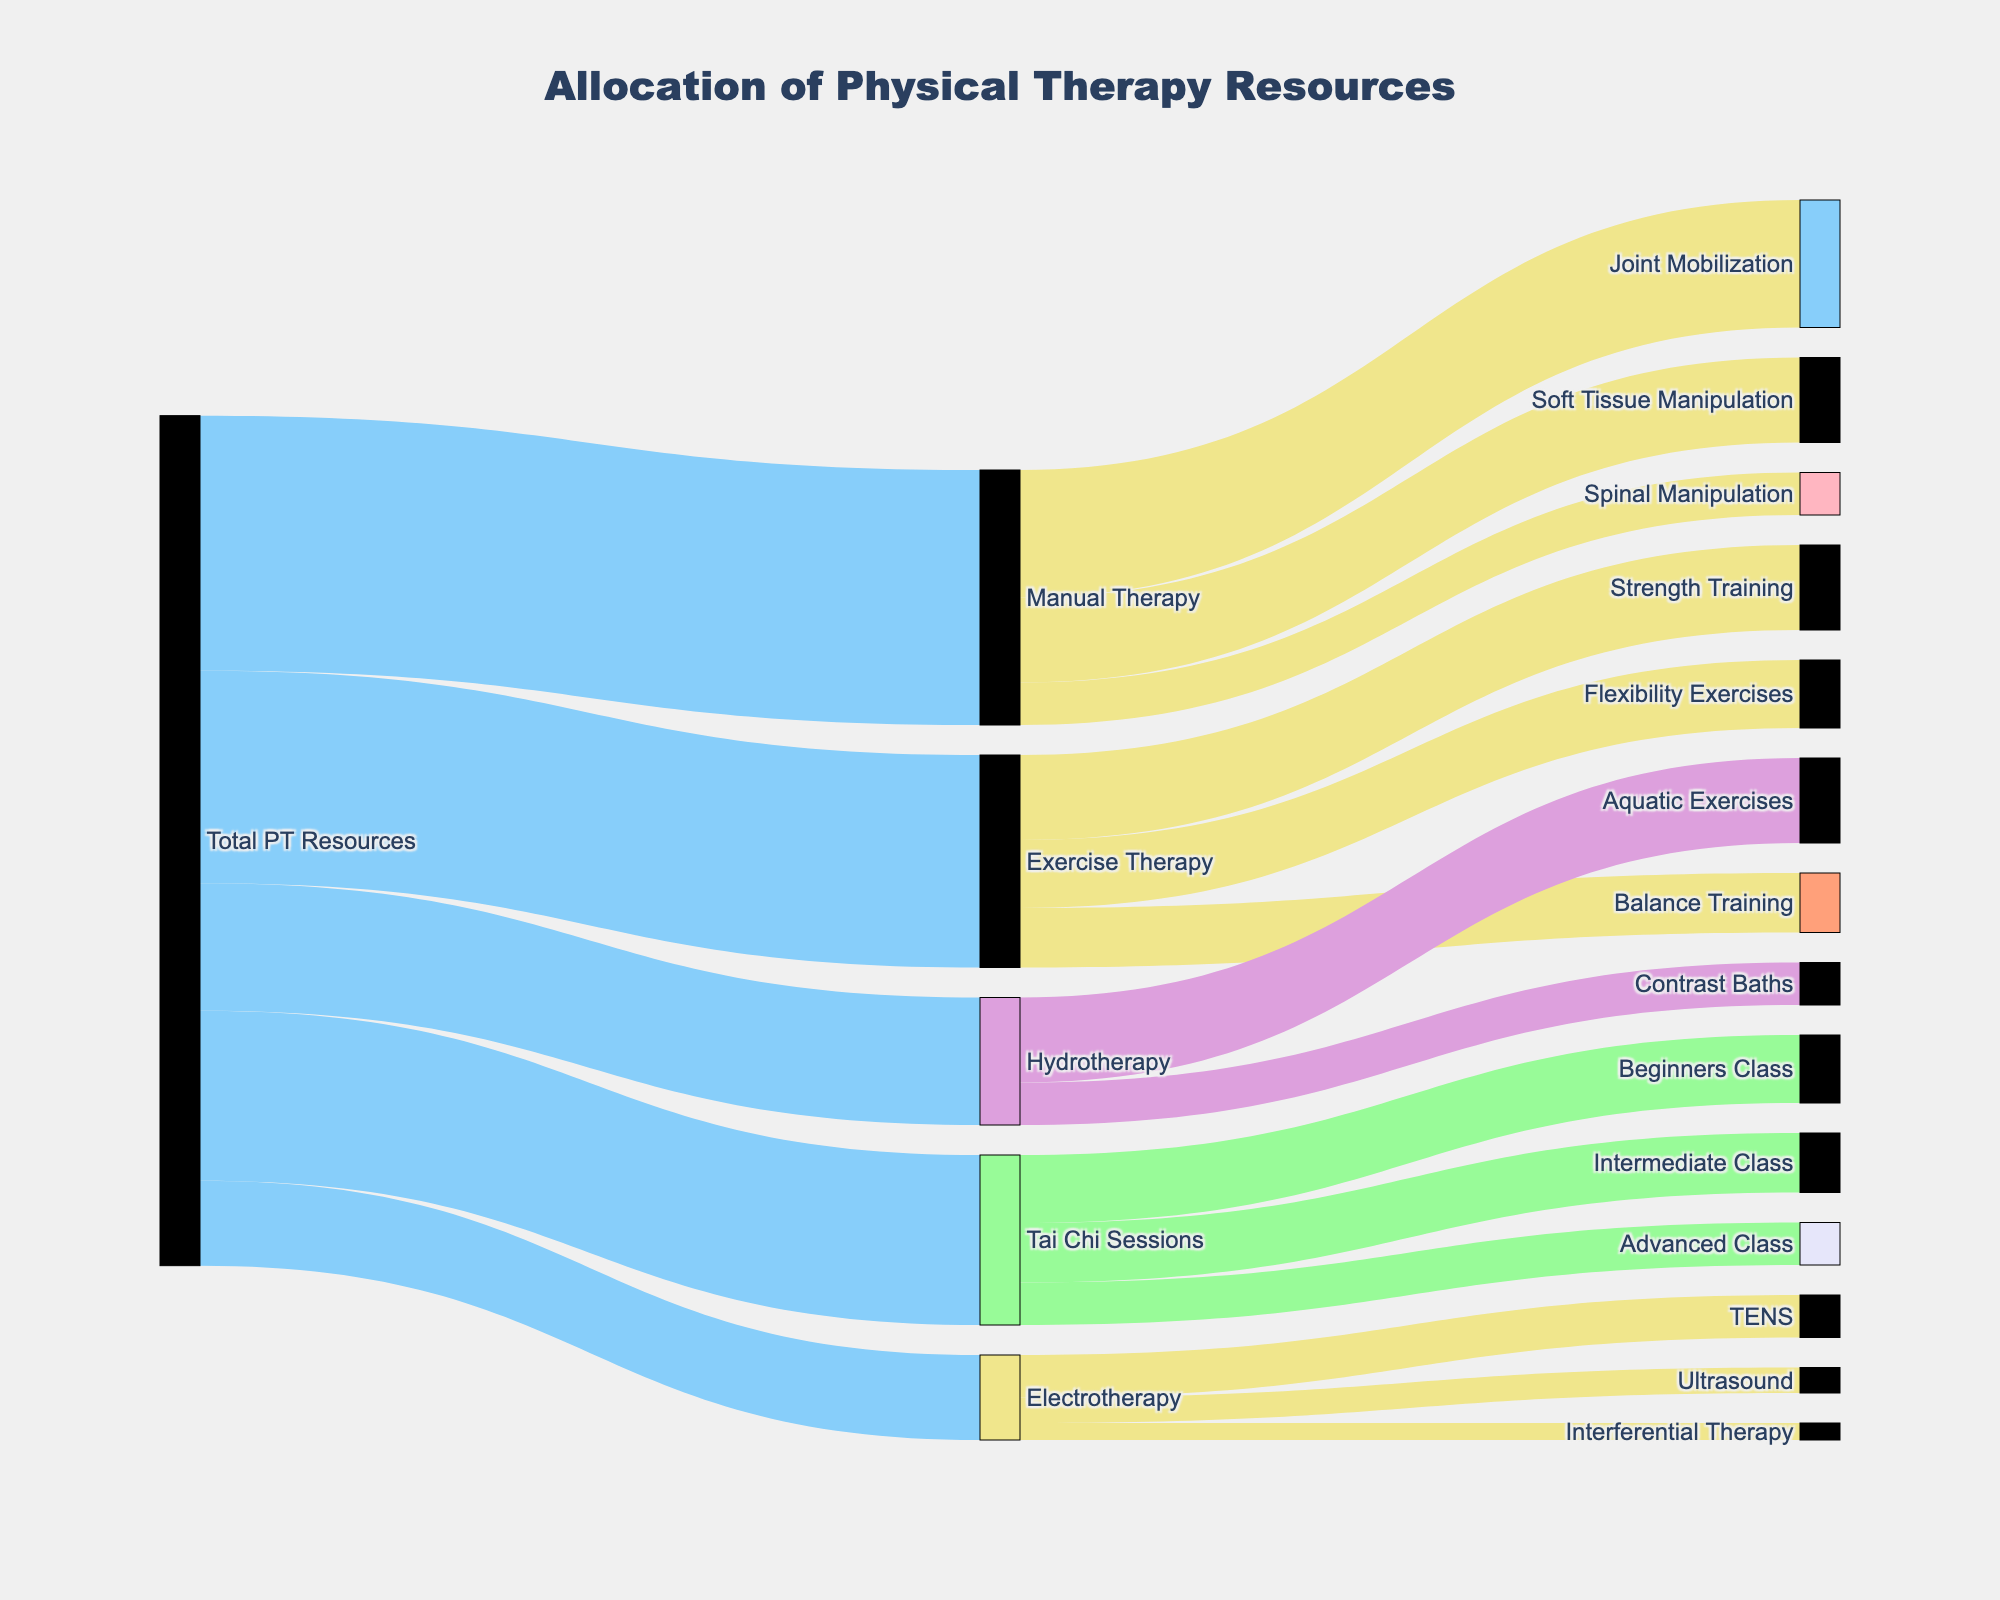What is the title of the figure? The title of the figure is displayed at the top and it reads "Allocation of Physical Therapy Resources".
Answer: Allocation of Physical Therapy Resources Which treatment modality received the most resources from the total physical therapy resources? The largest portion of the total physical therapy resources is allocated to Manual Therapy, as indicated by the widest link originating from "Total PT Resources" and flowing to "Manual Therapy".
Answer: Manual Therapy How many treatment modalities are listed for total physical therapy resources? By counting the number of distinct links originating from "Total PT Resources," we can identify five treatment modalities.
Answer: Five What is the combined value of the resources allocated to the Exercise Therapy subcategories? The subcategories under Exercise Therapy are Strength Training, Flexibility Exercises, and Balance Training, with values of 10, 8, and 7 respectively. Summing these up, 10 + 8 + 7 = 25.
Answer: 25 What is the value allocated to Tai Chi Sessions, and how does it compare to Hydrotherapy? The value allocated to Tai Chi Sessions is 20, while Hydrotherapy received 15. By comparison, Tai Chi Sessions have 5 more resources allocated than Hydrotherapy.
Answer: Tai Chi Sessions have 5 more resources than Hydrotherapy Which Tai Chi class received the least resources? By looking at the links originating from "Tai Chi Sessions" and checking their values, the class with the smallest value is the Advanced Class, receiving 5 resources.
Answer: Advanced Class How many total resources are split among the categories under Manual Therapy? The categories under Manual Therapy are Joint Mobilization (15), Soft Tissue Manipulation (10), and Spinal Manipulation (5). Summing these values, 15 + 10 + 5 = 30.
Answer: 30 Compare the allocation between Joint Mobilization and Spinal Manipulation within Manual Therapy. Joint Mobilization is allocated 15 resources, while Spinal Manipulation is allocated 5. Joint Mobilization receives three times the resources of Spinal Manipulation (15/5 = 3).
Answer: Joint Mobilization receives three times the resources How do the resources allocated to Electrotherapy compare with those allocated to Hydrotherapy? Electrotherapy received a total of 10 resources, while Hydrotherapy received 15. Hence, Hydrotherapy has 5 more resources allocated compared to Electrotherapy.
Answer: Hydrotherapy has 5 more resources What percentage of total physical therapy resources is allocated to Tai Chi Sessions? Tai Chi Sessions received 20 resources out of the total 100 physical therapy resources. To find the percentage, divide 20 by 100 and multiply by 100 (20/100 * 100 = 20%).
Answer: 20% 